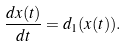<formula> <loc_0><loc_0><loc_500><loc_500>\frac { d x ( t ) } { d t } = d _ { 1 } ( x ( t ) ) .</formula> 